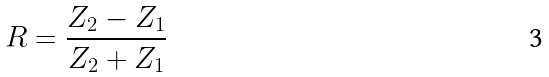Convert formula to latex. <formula><loc_0><loc_0><loc_500><loc_500>R = \frac { Z _ { 2 } - Z _ { 1 } } { Z _ { 2 } + Z _ { 1 } }</formula> 